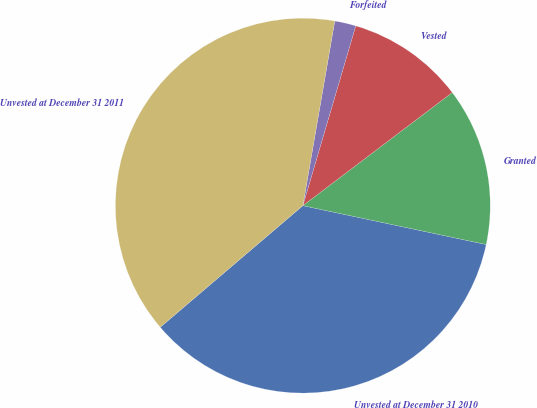Convert chart to OTSL. <chart><loc_0><loc_0><loc_500><loc_500><pie_chart><fcel>Unvested at December 31 2010<fcel>Granted<fcel>Vested<fcel>Forfeited<fcel>Unvested at December 31 2011<nl><fcel>35.44%<fcel>13.64%<fcel>10.13%<fcel>1.83%<fcel>38.96%<nl></chart> 